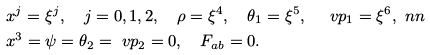Convert formula to latex. <formula><loc_0><loc_0><loc_500><loc_500>& x ^ { j } = \xi ^ { j } , \quad j = 0 , 1 , 2 , \quad \rho = \xi ^ { 4 } , \quad \theta _ { 1 } = \xi ^ { 5 } , \quad \ v p _ { 1 } = \xi ^ { 6 } , \ n n \\ & x ^ { 3 } = \psi = \theta _ { 2 } = \ v p _ { 2 } = 0 , \quad F _ { a b } = 0 .</formula> 